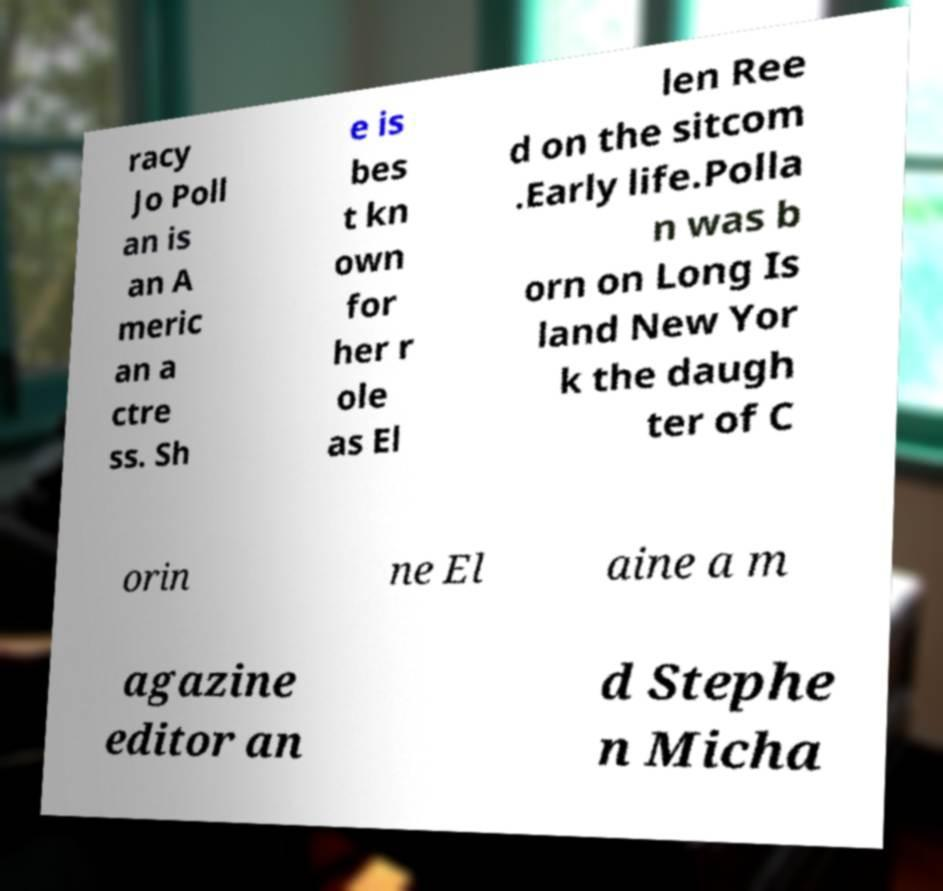What messages or text are displayed in this image? I need them in a readable, typed format. racy Jo Poll an is an A meric an a ctre ss. Sh e is bes t kn own for her r ole as El len Ree d on the sitcom .Early life.Polla n was b orn on Long Is land New Yor k the daugh ter of C orin ne El aine a m agazine editor an d Stephe n Micha 